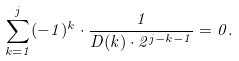Convert formula to latex. <formula><loc_0><loc_0><loc_500><loc_500>\sum _ { k = 1 } ^ { j } ( - 1 ) ^ { k } \cdot \frac { 1 } { D ( k ) \cdot 2 ^ { j - k - 1 } } = 0 .</formula> 